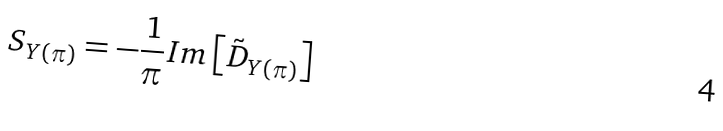<formula> <loc_0><loc_0><loc_500><loc_500>S _ { Y ( \pi ) } = - \frac { 1 } { \pi } I m \left [ \tilde { D } _ { Y ( \pi ) } \right ]</formula> 